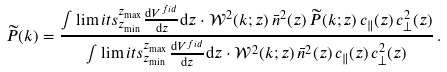<formula> <loc_0><loc_0><loc_500><loc_500>\widetilde { P } ( k ) = \frac { \int \lim i t s _ { z _ { \min } } ^ { z _ { \max } } \frac { { \mathrm d } V ^ { f i d } } { { \mathrm d } z } { \mathrm d } z \cdot \mathcal { W } ^ { 2 } ( k ; z ) \, \bar { n } ^ { 2 } ( z ) \, \widetilde { P } ( k ; z ) \, c _ { \| } ( z ) \, c _ { \perp } ^ { 2 } ( z ) } { \int \lim i t s _ { z _ { \min } } ^ { z _ { \max } } \frac { { \mathrm d } V ^ { f i d } } { { \mathrm d } z } { \mathrm d } z \cdot \mathcal { W } ^ { 2 } ( k ; z ) \, \bar { n } ^ { 2 } ( z ) \, c _ { \| } ( z ) \, c _ { \perp } ^ { 2 } ( z ) } \, .</formula> 